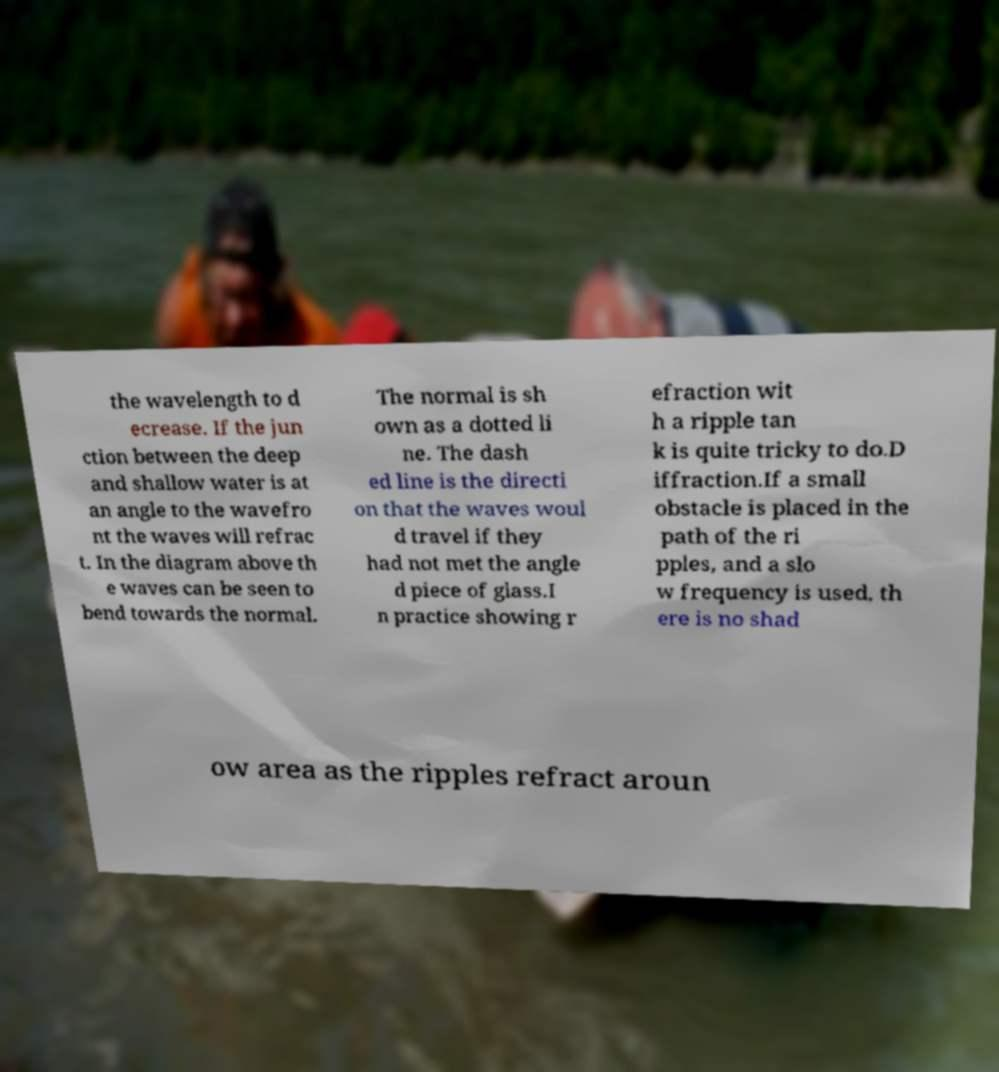Could you assist in decoding the text presented in this image and type it out clearly? the wavelength to d ecrease. If the jun ction between the deep and shallow water is at an angle to the wavefro nt the waves will refrac t. In the diagram above th e waves can be seen to bend towards the normal. The normal is sh own as a dotted li ne. The dash ed line is the directi on that the waves woul d travel if they had not met the angle d piece of glass.I n practice showing r efraction wit h a ripple tan k is quite tricky to do.D iffraction.If a small obstacle is placed in the path of the ri pples, and a slo w frequency is used, th ere is no shad ow area as the ripples refract aroun 